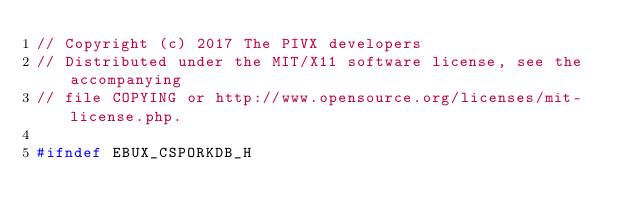<code> <loc_0><loc_0><loc_500><loc_500><_C_>// Copyright (c) 2017 The PIVX developers
// Distributed under the MIT/X11 software license, see the accompanying
// file COPYING or http://www.opensource.org/licenses/mit-license.php.

#ifndef EBUX_CSPORKDB_H</code> 